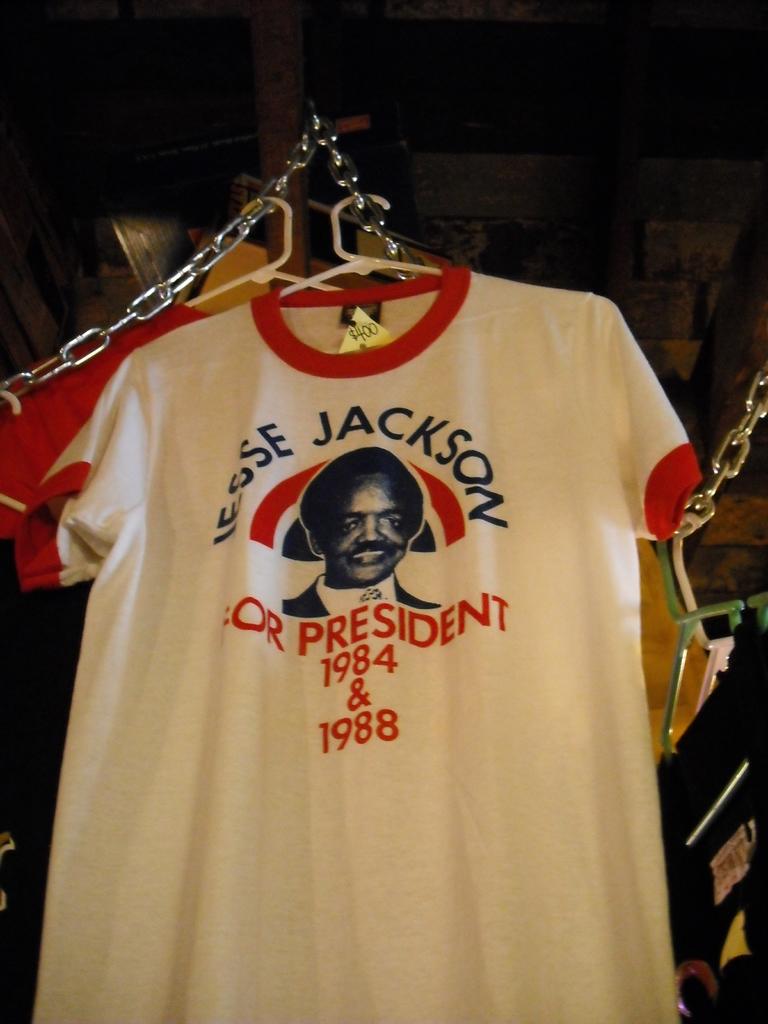In what years did jesse jackson run for president?
Give a very brief answer. 1984 & 1988. Who is on the shirt?
Offer a very short reply. Jesse jackson. 